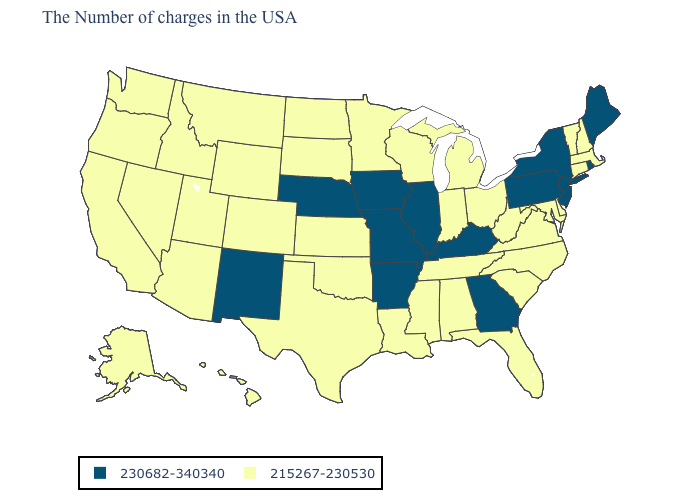What is the value of Alaska?
Keep it brief. 215267-230530. Name the states that have a value in the range 215267-230530?
Give a very brief answer. Massachusetts, New Hampshire, Vermont, Connecticut, Delaware, Maryland, Virginia, North Carolina, South Carolina, West Virginia, Ohio, Florida, Michigan, Indiana, Alabama, Tennessee, Wisconsin, Mississippi, Louisiana, Minnesota, Kansas, Oklahoma, Texas, South Dakota, North Dakota, Wyoming, Colorado, Utah, Montana, Arizona, Idaho, Nevada, California, Washington, Oregon, Alaska, Hawaii. What is the value of Illinois?
Concise answer only. 230682-340340. What is the value of Illinois?
Answer briefly. 230682-340340. Does Oregon have the same value as Iowa?
Concise answer only. No. Is the legend a continuous bar?
Keep it brief. No. What is the value of Utah?
Answer briefly. 215267-230530. Does the map have missing data?
Quick response, please. No. Among the states that border Virginia , does Kentucky have the highest value?
Keep it brief. Yes. Name the states that have a value in the range 230682-340340?
Keep it brief. Maine, Rhode Island, New York, New Jersey, Pennsylvania, Georgia, Kentucky, Illinois, Missouri, Arkansas, Iowa, Nebraska, New Mexico. Which states hav the highest value in the MidWest?
Quick response, please. Illinois, Missouri, Iowa, Nebraska. What is the highest value in the USA?
Be succinct. 230682-340340. Does Oregon have the same value as Missouri?
Short answer required. No. Name the states that have a value in the range 215267-230530?
Quick response, please. Massachusetts, New Hampshire, Vermont, Connecticut, Delaware, Maryland, Virginia, North Carolina, South Carolina, West Virginia, Ohio, Florida, Michigan, Indiana, Alabama, Tennessee, Wisconsin, Mississippi, Louisiana, Minnesota, Kansas, Oklahoma, Texas, South Dakota, North Dakota, Wyoming, Colorado, Utah, Montana, Arizona, Idaho, Nevada, California, Washington, Oregon, Alaska, Hawaii. What is the value of Delaware?
Answer briefly. 215267-230530. 